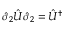<formula> <loc_0><loc_0><loc_500><loc_500>\hat { \sigma } _ { 2 } \hat { U } \hat { \sigma } _ { 2 } = \hat { U } ^ { \dagger }</formula> 